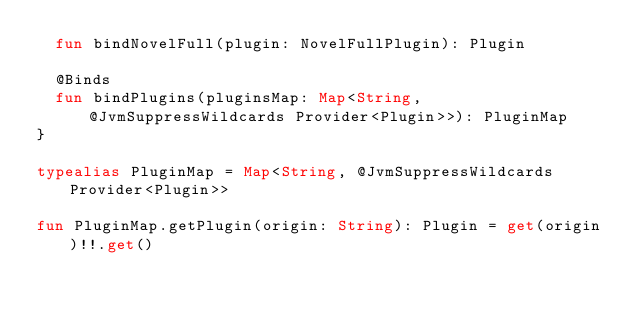Convert code to text. <code><loc_0><loc_0><loc_500><loc_500><_Kotlin_>  fun bindNovelFull(plugin: NovelFullPlugin): Plugin

  @Binds
  fun bindPlugins(pluginsMap: Map<String, @JvmSuppressWildcards Provider<Plugin>>): PluginMap
}

typealias PluginMap = Map<String, @JvmSuppressWildcards Provider<Plugin>>

fun PluginMap.getPlugin(origin: String): Plugin = get(origin)!!.get()</code> 